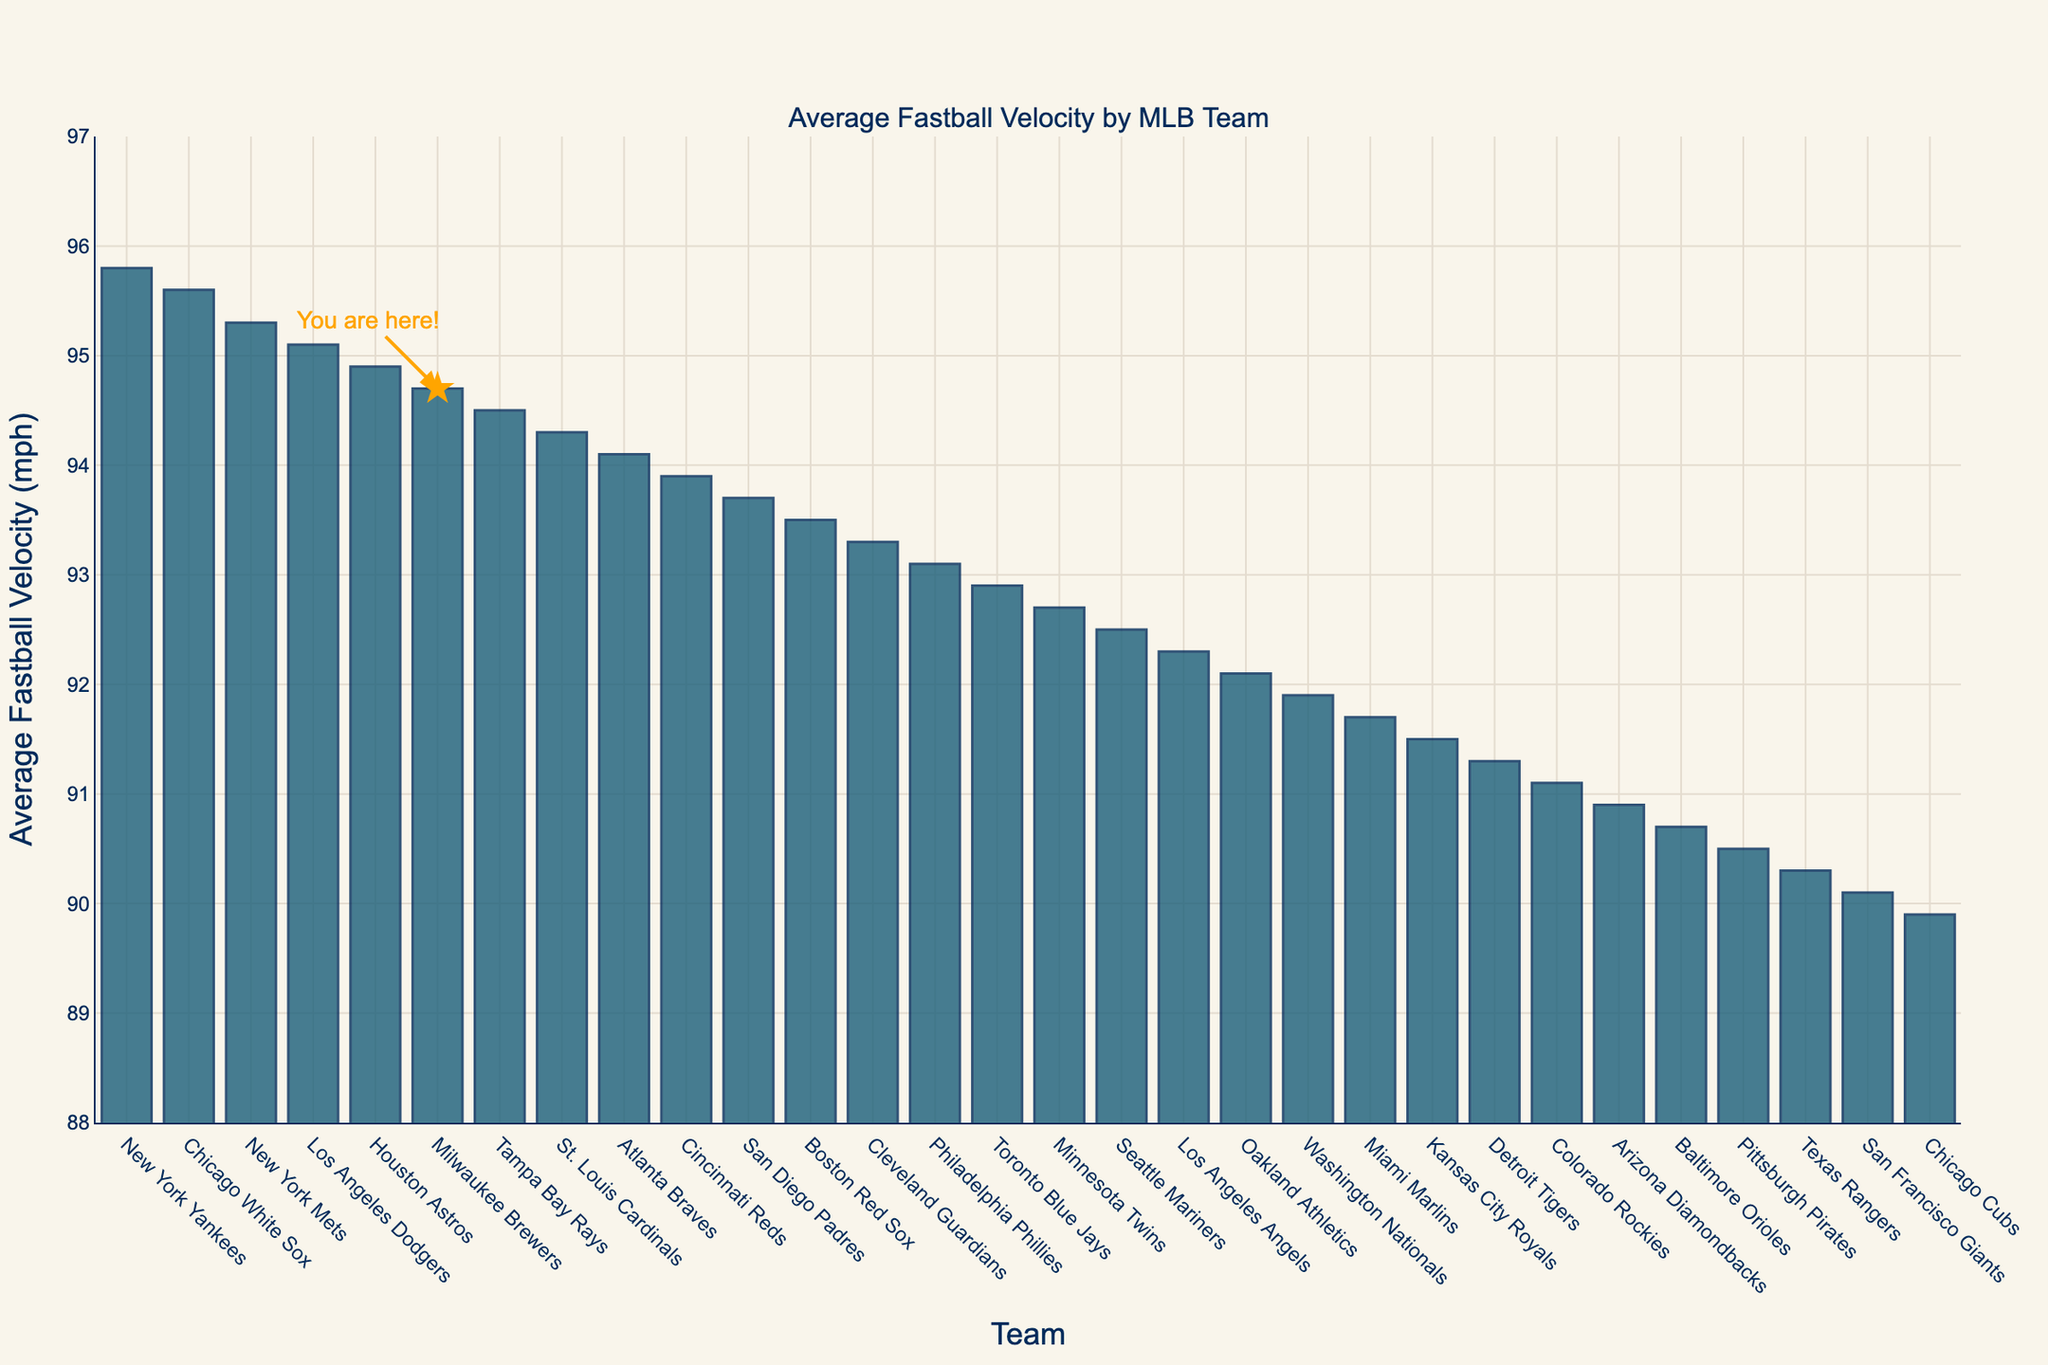What is the average fastball velocity of the Milwaukee Brewers? You can find the value on the y-axis corresponding to the bar labeled "Milwaukee Brewers." The velocity is labeled at 94.7 mph in the chart.
Answer: 94.7 Which team has the highest average fastball velocity? Find the tallest bar to identify the team and read the corresponding value. The New York Yankees have the highest average fastball velocity at 95.8 mph.
Answer: New York Yankees How much faster is the average fastball velocity of the New York Yankees compared to the Chicago Cubs? Subtract the average fastball velocity of the Chicago Cubs (89.9 mph) from the New York Yankees (95.8 mph): 95.8 - 89.9 = 5.9.
Answer: 5.9 mph Which teams have an average fastball velocity above 95 mph? Identify all bars that exceed 95 mph. The teams are the New York Yankees (95.8 mph), Chicago White Sox (95.6 mph), and New York Mets (95.3 mph).
Answer: New York Yankees, Chicago White Sox, New York Mets What is the difference in average fastball velocity between the Milwaukee Brewers and the average of their neighboring team on the list? The Milwaukee Brewers are at 94.7 mph. The neighboring teams are Houston Astros (94.9 mph) and Tampa Bay Rays (94.5 mph). First, calculate their average: (94.9 + 94.5) / 2 = 94.7 mph. The difference is 94.7 - 94.7 = 0.
Answer: 0 How much slower is the average fastball velocity of the Texas Rangers compared to the St. Louis Cardinals? Subtract the Texas Rangers' velocity (90.3 mph) from the St. Louis Cardinals' velocity (94.3 mph): 94.3 - 90.3 = 4.0.
Answer: 4.0 mph Which team is in the middle of the list based on average fastball velocity? The list has 30 teams. The middle team is the 15th team when sorted by descending velocity. This team is the Toronto Blue Jays, with an average velocity of 92.9 mph.
Answer: Toronto Blue Jays What is the visual highlight indicating the Milwaukee Brewers on the chart? There is a star marker and an annotation saying "You are here!" at the position of the Milwaukee Brewers on the bar chart.
Answer: Star marker Which team has the closest average fastball velocity to 93 mph? Identify the bar closest to 93 mph. The Philadelphia Phillies have an average fastball velocity of 93.1 mph, which is closest to 93 mph.
Answer: Philadelphia Phillies 